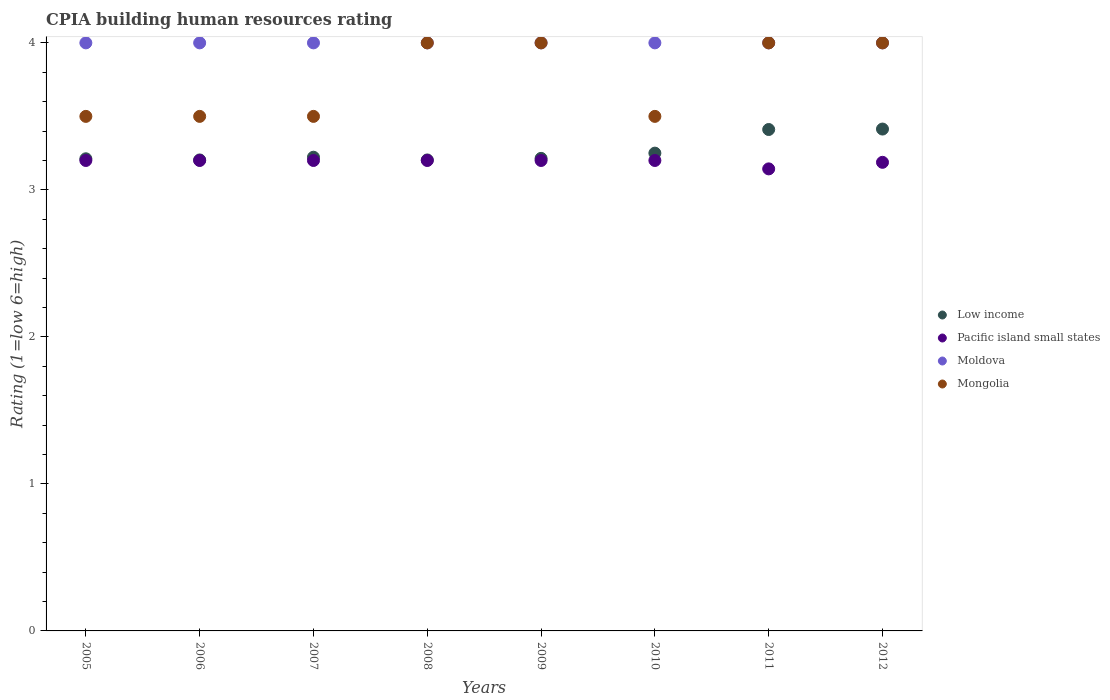In which year was the CPIA rating in Mongolia maximum?
Give a very brief answer. 2008. What is the total CPIA rating in Mongolia in the graph?
Provide a succinct answer. 30. What is the difference between the CPIA rating in Pacific island small states in 2012 and the CPIA rating in Low income in 2007?
Your response must be concise. -0.03. What is the average CPIA rating in Mongolia per year?
Your response must be concise. 3.75. In the year 2009, what is the difference between the CPIA rating in Mongolia and CPIA rating in Pacific island small states?
Offer a very short reply. 0.8. In how many years, is the CPIA rating in Mongolia greater than 2.2?
Provide a succinct answer. 8. Is the CPIA rating in Moldova in 2005 less than that in 2011?
Provide a succinct answer. No. Is the difference between the CPIA rating in Mongolia in 2005 and 2009 greater than the difference between the CPIA rating in Pacific island small states in 2005 and 2009?
Give a very brief answer. No. What is the difference between the highest and the lowest CPIA rating in Low income?
Give a very brief answer. 0.21. In how many years, is the CPIA rating in Low income greater than the average CPIA rating in Low income taken over all years?
Give a very brief answer. 2. Is the sum of the CPIA rating in Pacific island small states in 2009 and 2010 greater than the maximum CPIA rating in Mongolia across all years?
Keep it short and to the point. Yes. Is it the case that in every year, the sum of the CPIA rating in Pacific island small states and CPIA rating in Low income  is greater than the CPIA rating in Moldova?
Offer a terse response. Yes. Does the CPIA rating in Pacific island small states monotonically increase over the years?
Your response must be concise. No. Is the CPIA rating in Pacific island small states strictly greater than the CPIA rating in Low income over the years?
Offer a terse response. No. Is the CPIA rating in Mongolia strictly less than the CPIA rating in Pacific island small states over the years?
Make the answer very short. No. How many dotlines are there?
Offer a terse response. 4. How many years are there in the graph?
Keep it short and to the point. 8. Are the values on the major ticks of Y-axis written in scientific E-notation?
Offer a very short reply. No. Does the graph contain any zero values?
Keep it short and to the point. No. Does the graph contain grids?
Your answer should be compact. No. Where does the legend appear in the graph?
Make the answer very short. Center right. How many legend labels are there?
Ensure brevity in your answer.  4. How are the legend labels stacked?
Offer a very short reply. Vertical. What is the title of the graph?
Your answer should be compact. CPIA building human resources rating. What is the label or title of the Y-axis?
Keep it short and to the point. Rating (1=low 6=high). What is the Rating (1=low 6=high) in Low income in 2005?
Your answer should be compact. 3.21. What is the Rating (1=low 6=high) in Mongolia in 2005?
Offer a terse response. 3.5. What is the Rating (1=low 6=high) in Low income in 2006?
Make the answer very short. 3.2. What is the Rating (1=low 6=high) of Pacific island small states in 2006?
Provide a succinct answer. 3.2. What is the Rating (1=low 6=high) of Moldova in 2006?
Your response must be concise. 4. What is the Rating (1=low 6=high) of Low income in 2007?
Your answer should be very brief. 3.22. What is the Rating (1=low 6=high) of Moldova in 2007?
Ensure brevity in your answer.  4. What is the Rating (1=low 6=high) of Low income in 2008?
Your answer should be compact. 3.2. What is the Rating (1=low 6=high) of Moldova in 2008?
Your response must be concise. 4. What is the Rating (1=low 6=high) in Mongolia in 2008?
Keep it short and to the point. 4. What is the Rating (1=low 6=high) of Low income in 2009?
Your response must be concise. 3.21. What is the Rating (1=low 6=high) in Low income in 2010?
Give a very brief answer. 3.25. What is the Rating (1=low 6=high) of Pacific island small states in 2010?
Offer a very short reply. 3.2. What is the Rating (1=low 6=high) in Moldova in 2010?
Provide a succinct answer. 4. What is the Rating (1=low 6=high) of Low income in 2011?
Your response must be concise. 3.41. What is the Rating (1=low 6=high) in Pacific island small states in 2011?
Offer a terse response. 3.14. What is the Rating (1=low 6=high) in Moldova in 2011?
Provide a short and direct response. 4. What is the Rating (1=low 6=high) of Mongolia in 2011?
Keep it short and to the point. 4. What is the Rating (1=low 6=high) of Low income in 2012?
Make the answer very short. 3.41. What is the Rating (1=low 6=high) in Pacific island small states in 2012?
Provide a succinct answer. 3.19. Across all years, what is the maximum Rating (1=low 6=high) in Low income?
Provide a short and direct response. 3.41. Across all years, what is the maximum Rating (1=low 6=high) in Pacific island small states?
Offer a terse response. 3.2. Across all years, what is the maximum Rating (1=low 6=high) of Moldova?
Your answer should be very brief. 4. Across all years, what is the minimum Rating (1=low 6=high) of Low income?
Provide a short and direct response. 3.2. Across all years, what is the minimum Rating (1=low 6=high) of Pacific island small states?
Ensure brevity in your answer.  3.14. Across all years, what is the minimum Rating (1=low 6=high) in Moldova?
Your answer should be compact. 4. Across all years, what is the minimum Rating (1=low 6=high) of Mongolia?
Ensure brevity in your answer.  3.5. What is the total Rating (1=low 6=high) in Low income in the graph?
Provide a succinct answer. 26.13. What is the total Rating (1=low 6=high) in Pacific island small states in the graph?
Provide a succinct answer. 25.53. What is the total Rating (1=low 6=high) of Moldova in the graph?
Give a very brief answer. 32. What is the difference between the Rating (1=low 6=high) of Low income in 2005 and that in 2006?
Make the answer very short. 0.01. What is the difference between the Rating (1=low 6=high) of Pacific island small states in 2005 and that in 2006?
Provide a short and direct response. 0. What is the difference between the Rating (1=low 6=high) in Low income in 2005 and that in 2007?
Your answer should be very brief. -0.01. What is the difference between the Rating (1=low 6=high) of Pacific island small states in 2005 and that in 2007?
Offer a very short reply. 0. What is the difference between the Rating (1=low 6=high) in Moldova in 2005 and that in 2007?
Your answer should be very brief. 0. What is the difference between the Rating (1=low 6=high) in Mongolia in 2005 and that in 2007?
Make the answer very short. 0. What is the difference between the Rating (1=low 6=high) in Low income in 2005 and that in 2008?
Give a very brief answer. 0.01. What is the difference between the Rating (1=low 6=high) in Moldova in 2005 and that in 2008?
Provide a succinct answer. 0. What is the difference between the Rating (1=low 6=high) of Mongolia in 2005 and that in 2008?
Keep it short and to the point. -0.5. What is the difference between the Rating (1=low 6=high) of Low income in 2005 and that in 2009?
Give a very brief answer. -0. What is the difference between the Rating (1=low 6=high) of Pacific island small states in 2005 and that in 2009?
Provide a succinct answer. 0. What is the difference between the Rating (1=low 6=high) of Mongolia in 2005 and that in 2009?
Keep it short and to the point. -0.5. What is the difference between the Rating (1=low 6=high) of Low income in 2005 and that in 2010?
Keep it short and to the point. -0.04. What is the difference between the Rating (1=low 6=high) in Pacific island small states in 2005 and that in 2010?
Ensure brevity in your answer.  0. What is the difference between the Rating (1=low 6=high) in Moldova in 2005 and that in 2010?
Provide a short and direct response. 0. What is the difference between the Rating (1=low 6=high) in Low income in 2005 and that in 2011?
Keep it short and to the point. -0.2. What is the difference between the Rating (1=low 6=high) of Pacific island small states in 2005 and that in 2011?
Your answer should be very brief. 0.06. What is the difference between the Rating (1=low 6=high) of Moldova in 2005 and that in 2011?
Keep it short and to the point. 0. What is the difference between the Rating (1=low 6=high) of Mongolia in 2005 and that in 2011?
Ensure brevity in your answer.  -0.5. What is the difference between the Rating (1=low 6=high) of Low income in 2005 and that in 2012?
Ensure brevity in your answer.  -0.2. What is the difference between the Rating (1=low 6=high) in Pacific island small states in 2005 and that in 2012?
Give a very brief answer. 0.01. What is the difference between the Rating (1=low 6=high) in Moldova in 2005 and that in 2012?
Your answer should be very brief. 0. What is the difference between the Rating (1=low 6=high) in Mongolia in 2005 and that in 2012?
Your answer should be very brief. -0.5. What is the difference between the Rating (1=low 6=high) in Low income in 2006 and that in 2007?
Offer a terse response. -0.02. What is the difference between the Rating (1=low 6=high) of Pacific island small states in 2006 and that in 2007?
Keep it short and to the point. 0. What is the difference between the Rating (1=low 6=high) in Mongolia in 2006 and that in 2007?
Provide a succinct answer. 0. What is the difference between the Rating (1=low 6=high) of Low income in 2006 and that in 2008?
Provide a succinct answer. 0. What is the difference between the Rating (1=low 6=high) of Pacific island small states in 2006 and that in 2008?
Give a very brief answer. 0. What is the difference between the Rating (1=low 6=high) of Moldova in 2006 and that in 2008?
Your answer should be very brief. 0. What is the difference between the Rating (1=low 6=high) in Mongolia in 2006 and that in 2008?
Give a very brief answer. -0.5. What is the difference between the Rating (1=low 6=high) of Low income in 2006 and that in 2009?
Provide a succinct answer. -0.01. What is the difference between the Rating (1=low 6=high) of Pacific island small states in 2006 and that in 2009?
Give a very brief answer. 0. What is the difference between the Rating (1=low 6=high) of Moldova in 2006 and that in 2009?
Your answer should be compact. 0. What is the difference between the Rating (1=low 6=high) of Mongolia in 2006 and that in 2009?
Ensure brevity in your answer.  -0.5. What is the difference between the Rating (1=low 6=high) of Low income in 2006 and that in 2010?
Give a very brief answer. -0.05. What is the difference between the Rating (1=low 6=high) of Pacific island small states in 2006 and that in 2010?
Ensure brevity in your answer.  0. What is the difference between the Rating (1=low 6=high) of Low income in 2006 and that in 2011?
Provide a succinct answer. -0.21. What is the difference between the Rating (1=low 6=high) in Pacific island small states in 2006 and that in 2011?
Give a very brief answer. 0.06. What is the difference between the Rating (1=low 6=high) in Low income in 2006 and that in 2012?
Provide a short and direct response. -0.21. What is the difference between the Rating (1=low 6=high) in Pacific island small states in 2006 and that in 2012?
Give a very brief answer. 0.01. What is the difference between the Rating (1=low 6=high) in Moldova in 2006 and that in 2012?
Ensure brevity in your answer.  0. What is the difference between the Rating (1=low 6=high) in Mongolia in 2006 and that in 2012?
Your answer should be very brief. -0.5. What is the difference between the Rating (1=low 6=high) in Low income in 2007 and that in 2008?
Give a very brief answer. 0.02. What is the difference between the Rating (1=low 6=high) in Moldova in 2007 and that in 2008?
Offer a terse response. 0. What is the difference between the Rating (1=low 6=high) in Mongolia in 2007 and that in 2008?
Keep it short and to the point. -0.5. What is the difference between the Rating (1=low 6=high) of Low income in 2007 and that in 2009?
Give a very brief answer. 0.01. What is the difference between the Rating (1=low 6=high) of Mongolia in 2007 and that in 2009?
Provide a short and direct response. -0.5. What is the difference between the Rating (1=low 6=high) in Low income in 2007 and that in 2010?
Your answer should be compact. -0.03. What is the difference between the Rating (1=low 6=high) in Pacific island small states in 2007 and that in 2010?
Your answer should be compact. 0. What is the difference between the Rating (1=low 6=high) of Moldova in 2007 and that in 2010?
Your response must be concise. 0. What is the difference between the Rating (1=low 6=high) of Mongolia in 2007 and that in 2010?
Give a very brief answer. 0. What is the difference between the Rating (1=low 6=high) in Low income in 2007 and that in 2011?
Provide a succinct answer. -0.19. What is the difference between the Rating (1=low 6=high) of Pacific island small states in 2007 and that in 2011?
Your answer should be very brief. 0.06. What is the difference between the Rating (1=low 6=high) in Mongolia in 2007 and that in 2011?
Make the answer very short. -0.5. What is the difference between the Rating (1=low 6=high) in Low income in 2007 and that in 2012?
Your answer should be compact. -0.19. What is the difference between the Rating (1=low 6=high) in Pacific island small states in 2007 and that in 2012?
Give a very brief answer. 0.01. What is the difference between the Rating (1=low 6=high) in Moldova in 2007 and that in 2012?
Keep it short and to the point. 0. What is the difference between the Rating (1=low 6=high) of Mongolia in 2007 and that in 2012?
Offer a very short reply. -0.5. What is the difference between the Rating (1=low 6=high) in Low income in 2008 and that in 2009?
Your answer should be very brief. -0.01. What is the difference between the Rating (1=low 6=high) of Pacific island small states in 2008 and that in 2009?
Your answer should be very brief. 0. What is the difference between the Rating (1=low 6=high) of Mongolia in 2008 and that in 2009?
Offer a terse response. 0. What is the difference between the Rating (1=low 6=high) of Low income in 2008 and that in 2010?
Your response must be concise. -0.05. What is the difference between the Rating (1=low 6=high) in Moldova in 2008 and that in 2010?
Provide a short and direct response. 0. What is the difference between the Rating (1=low 6=high) of Mongolia in 2008 and that in 2010?
Keep it short and to the point. 0.5. What is the difference between the Rating (1=low 6=high) of Low income in 2008 and that in 2011?
Your answer should be very brief. -0.21. What is the difference between the Rating (1=low 6=high) of Pacific island small states in 2008 and that in 2011?
Give a very brief answer. 0.06. What is the difference between the Rating (1=low 6=high) of Low income in 2008 and that in 2012?
Your response must be concise. -0.21. What is the difference between the Rating (1=low 6=high) of Pacific island small states in 2008 and that in 2012?
Ensure brevity in your answer.  0.01. What is the difference between the Rating (1=low 6=high) in Moldova in 2008 and that in 2012?
Make the answer very short. 0. What is the difference between the Rating (1=low 6=high) in Mongolia in 2008 and that in 2012?
Provide a short and direct response. 0. What is the difference between the Rating (1=low 6=high) in Low income in 2009 and that in 2010?
Ensure brevity in your answer.  -0.04. What is the difference between the Rating (1=low 6=high) of Moldova in 2009 and that in 2010?
Offer a terse response. 0. What is the difference between the Rating (1=low 6=high) in Mongolia in 2009 and that in 2010?
Your response must be concise. 0.5. What is the difference between the Rating (1=low 6=high) of Low income in 2009 and that in 2011?
Your answer should be compact. -0.2. What is the difference between the Rating (1=low 6=high) of Pacific island small states in 2009 and that in 2011?
Your answer should be very brief. 0.06. What is the difference between the Rating (1=low 6=high) in Low income in 2009 and that in 2012?
Make the answer very short. -0.2. What is the difference between the Rating (1=low 6=high) of Pacific island small states in 2009 and that in 2012?
Offer a terse response. 0.01. What is the difference between the Rating (1=low 6=high) of Moldova in 2009 and that in 2012?
Give a very brief answer. 0. What is the difference between the Rating (1=low 6=high) of Low income in 2010 and that in 2011?
Make the answer very short. -0.16. What is the difference between the Rating (1=low 6=high) of Pacific island small states in 2010 and that in 2011?
Keep it short and to the point. 0.06. What is the difference between the Rating (1=low 6=high) of Mongolia in 2010 and that in 2011?
Provide a succinct answer. -0.5. What is the difference between the Rating (1=low 6=high) of Low income in 2010 and that in 2012?
Give a very brief answer. -0.16. What is the difference between the Rating (1=low 6=high) of Pacific island small states in 2010 and that in 2012?
Your response must be concise. 0.01. What is the difference between the Rating (1=low 6=high) of Moldova in 2010 and that in 2012?
Provide a succinct answer. 0. What is the difference between the Rating (1=low 6=high) of Mongolia in 2010 and that in 2012?
Make the answer very short. -0.5. What is the difference between the Rating (1=low 6=high) of Low income in 2011 and that in 2012?
Give a very brief answer. -0. What is the difference between the Rating (1=low 6=high) in Pacific island small states in 2011 and that in 2012?
Give a very brief answer. -0.04. What is the difference between the Rating (1=low 6=high) of Mongolia in 2011 and that in 2012?
Make the answer very short. 0. What is the difference between the Rating (1=low 6=high) in Low income in 2005 and the Rating (1=low 6=high) in Pacific island small states in 2006?
Your response must be concise. 0.01. What is the difference between the Rating (1=low 6=high) in Low income in 2005 and the Rating (1=low 6=high) in Moldova in 2006?
Your response must be concise. -0.79. What is the difference between the Rating (1=low 6=high) in Low income in 2005 and the Rating (1=low 6=high) in Mongolia in 2006?
Ensure brevity in your answer.  -0.29. What is the difference between the Rating (1=low 6=high) of Pacific island small states in 2005 and the Rating (1=low 6=high) of Mongolia in 2006?
Your answer should be very brief. -0.3. What is the difference between the Rating (1=low 6=high) of Low income in 2005 and the Rating (1=low 6=high) of Pacific island small states in 2007?
Keep it short and to the point. 0.01. What is the difference between the Rating (1=low 6=high) in Low income in 2005 and the Rating (1=low 6=high) in Moldova in 2007?
Provide a succinct answer. -0.79. What is the difference between the Rating (1=low 6=high) in Low income in 2005 and the Rating (1=low 6=high) in Mongolia in 2007?
Your response must be concise. -0.29. What is the difference between the Rating (1=low 6=high) of Low income in 2005 and the Rating (1=low 6=high) of Pacific island small states in 2008?
Offer a terse response. 0.01. What is the difference between the Rating (1=low 6=high) of Low income in 2005 and the Rating (1=low 6=high) of Moldova in 2008?
Keep it short and to the point. -0.79. What is the difference between the Rating (1=low 6=high) in Low income in 2005 and the Rating (1=low 6=high) in Mongolia in 2008?
Ensure brevity in your answer.  -0.79. What is the difference between the Rating (1=low 6=high) in Moldova in 2005 and the Rating (1=low 6=high) in Mongolia in 2008?
Keep it short and to the point. 0. What is the difference between the Rating (1=low 6=high) in Low income in 2005 and the Rating (1=low 6=high) in Pacific island small states in 2009?
Ensure brevity in your answer.  0.01. What is the difference between the Rating (1=low 6=high) of Low income in 2005 and the Rating (1=low 6=high) of Moldova in 2009?
Provide a succinct answer. -0.79. What is the difference between the Rating (1=low 6=high) in Low income in 2005 and the Rating (1=low 6=high) in Mongolia in 2009?
Offer a very short reply. -0.79. What is the difference between the Rating (1=low 6=high) in Pacific island small states in 2005 and the Rating (1=low 6=high) in Mongolia in 2009?
Make the answer very short. -0.8. What is the difference between the Rating (1=low 6=high) in Moldova in 2005 and the Rating (1=low 6=high) in Mongolia in 2009?
Your answer should be very brief. 0. What is the difference between the Rating (1=low 6=high) in Low income in 2005 and the Rating (1=low 6=high) in Pacific island small states in 2010?
Your answer should be very brief. 0.01. What is the difference between the Rating (1=low 6=high) in Low income in 2005 and the Rating (1=low 6=high) in Moldova in 2010?
Provide a succinct answer. -0.79. What is the difference between the Rating (1=low 6=high) of Low income in 2005 and the Rating (1=low 6=high) of Mongolia in 2010?
Offer a very short reply. -0.29. What is the difference between the Rating (1=low 6=high) of Pacific island small states in 2005 and the Rating (1=low 6=high) of Mongolia in 2010?
Offer a terse response. -0.3. What is the difference between the Rating (1=low 6=high) in Moldova in 2005 and the Rating (1=low 6=high) in Mongolia in 2010?
Give a very brief answer. 0.5. What is the difference between the Rating (1=low 6=high) of Low income in 2005 and the Rating (1=low 6=high) of Pacific island small states in 2011?
Provide a succinct answer. 0.07. What is the difference between the Rating (1=low 6=high) of Low income in 2005 and the Rating (1=low 6=high) of Moldova in 2011?
Offer a very short reply. -0.79. What is the difference between the Rating (1=low 6=high) in Low income in 2005 and the Rating (1=low 6=high) in Mongolia in 2011?
Offer a very short reply. -0.79. What is the difference between the Rating (1=low 6=high) of Moldova in 2005 and the Rating (1=low 6=high) of Mongolia in 2011?
Your answer should be compact. 0. What is the difference between the Rating (1=low 6=high) of Low income in 2005 and the Rating (1=low 6=high) of Pacific island small states in 2012?
Ensure brevity in your answer.  0.02. What is the difference between the Rating (1=low 6=high) in Low income in 2005 and the Rating (1=low 6=high) in Moldova in 2012?
Make the answer very short. -0.79. What is the difference between the Rating (1=low 6=high) in Low income in 2005 and the Rating (1=low 6=high) in Mongolia in 2012?
Provide a short and direct response. -0.79. What is the difference between the Rating (1=low 6=high) of Pacific island small states in 2005 and the Rating (1=low 6=high) of Moldova in 2012?
Make the answer very short. -0.8. What is the difference between the Rating (1=low 6=high) of Moldova in 2005 and the Rating (1=low 6=high) of Mongolia in 2012?
Offer a terse response. 0. What is the difference between the Rating (1=low 6=high) in Low income in 2006 and the Rating (1=low 6=high) in Pacific island small states in 2007?
Your response must be concise. 0. What is the difference between the Rating (1=low 6=high) in Low income in 2006 and the Rating (1=low 6=high) in Moldova in 2007?
Offer a terse response. -0.8. What is the difference between the Rating (1=low 6=high) of Low income in 2006 and the Rating (1=low 6=high) of Mongolia in 2007?
Provide a succinct answer. -0.3. What is the difference between the Rating (1=low 6=high) of Pacific island small states in 2006 and the Rating (1=low 6=high) of Mongolia in 2007?
Keep it short and to the point. -0.3. What is the difference between the Rating (1=low 6=high) in Low income in 2006 and the Rating (1=low 6=high) in Pacific island small states in 2008?
Provide a short and direct response. 0. What is the difference between the Rating (1=low 6=high) of Low income in 2006 and the Rating (1=low 6=high) of Moldova in 2008?
Make the answer very short. -0.8. What is the difference between the Rating (1=low 6=high) of Low income in 2006 and the Rating (1=low 6=high) of Mongolia in 2008?
Offer a terse response. -0.8. What is the difference between the Rating (1=low 6=high) in Pacific island small states in 2006 and the Rating (1=low 6=high) in Mongolia in 2008?
Your response must be concise. -0.8. What is the difference between the Rating (1=low 6=high) in Low income in 2006 and the Rating (1=low 6=high) in Pacific island small states in 2009?
Your answer should be compact. 0. What is the difference between the Rating (1=low 6=high) of Low income in 2006 and the Rating (1=low 6=high) of Moldova in 2009?
Offer a very short reply. -0.8. What is the difference between the Rating (1=low 6=high) of Low income in 2006 and the Rating (1=low 6=high) of Mongolia in 2009?
Your response must be concise. -0.8. What is the difference between the Rating (1=low 6=high) in Pacific island small states in 2006 and the Rating (1=low 6=high) in Moldova in 2009?
Offer a terse response. -0.8. What is the difference between the Rating (1=low 6=high) of Pacific island small states in 2006 and the Rating (1=low 6=high) of Mongolia in 2009?
Give a very brief answer. -0.8. What is the difference between the Rating (1=low 6=high) in Low income in 2006 and the Rating (1=low 6=high) in Pacific island small states in 2010?
Your answer should be very brief. 0. What is the difference between the Rating (1=low 6=high) of Low income in 2006 and the Rating (1=low 6=high) of Moldova in 2010?
Offer a very short reply. -0.8. What is the difference between the Rating (1=low 6=high) of Low income in 2006 and the Rating (1=low 6=high) of Mongolia in 2010?
Offer a terse response. -0.3. What is the difference between the Rating (1=low 6=high) in Pacific island small states in 2006 and the Rating (1=low 6=high) in Moldova in 2010?
Make the answer very short. -0.8. What is the difference between the Rating (1=low 6=high) of Pacific island small states in 2006 and the Rating (1=low 6=high) of Mongolia in 2010?
Ensure brevity in your answer.  -0.3. What is the difference between the Rating (1=low 6=high) of Moldova in 2006 and the Rating (1=low 6=high) of Mongolia in 2010?
Give a very brief answer. 0.5. What is the difference between the Rating (1=low 6=high) of Low income in 2006 and the Rating (1=low 6=high) of Pacific island small states in 2011?
Your response must be concise. 0.06. What is the difference between the Rating (1=low 6=high) in Low income in 2006 and the Rating (1=low 6=high) in Moldova in 2011?
Make the answer very short. -0.8. What is the difference between the Rating (1=low 6=high) in Low income in 2006 and the Rating (1=low 6=high) in Mongolia in 2011?
Make the answer very short. -0.8. What is the difference between the Rating (1=low 6=high) in Pacific island small states in 2006 and the Rating (1=low 6=high) in Mongolia in 2011?
Offer a terse response. -0.8. What is the difference between the Rating (1=low 6=high) of Low income in 2006 and the Rating (1=low 6=high) of Pacific island small states in 2012?
Offer a very short reply. 0.02. What is the difference between the Rating (1=low 6=high) in Low income in 2006 and the Rating (1=low 6=high) in Moldova in 2012?
Make the answer very short. -0.8. What is the difference between the Rating (1=low 6=high) of Low income in 2006 and the Rating (1=low 6=high) of Mongolia in 2012?
Ensure brevity in your answer.  -0.8. What is the difference between the Rating (1=low 6=high) in Pacific island small states in 2006 and the Rating (1=low 6=high) in Moldova in 2012?
Offer a very short reply. -0.8. What is the difference between the Rating (1=low 6=high) of Pacific island small states in 2006 and the Rating (1=low 6=high) of Mongolia in 2012?
Offer a very short reply. -0.8. What is the difference between the Rating (1=low 6=high) of Moldova in 2006 and the Rating (1=low 6=high) of Mongolia in 2012?
Your answer should be very brief. 0. What is the difference between the Rating (1=low 6=high) in Low income in 2007 and the Rating (1=low 6=high) in Pacific island small states in 2008?
Give a very brief answer. 0.02. What is the difference between the Rating (1=low 6=high) in Low income in 2007 and the Rating (1=low 6=high) in Moldova in 2008?
Offer a very short reply. -0.78. What is the difference between the Rating (1=low 6=high) in Low income in 2007 and the Rating (1=low 6=high) in Mongolia in 2008?
Ensure brevity in your answer.  -0.78. What is the difference between the Rating (1=low 6=high) of Pacific island small states in 2007 and the Rating (1=low 6=high) of Mongolia in 2008?
Your answer should be compact. -0.8. What is the difference between the Rating (1=low 6=high) in Low income in 2007 and the Rating (1=low 6=high) in Pacific island small states in 2009?
Your answer should be very brief. 0.02. What is the difference between the Rating (1=low 6=high) of Low income in 2007 and the Rating (1=low 6=high) of Moldova in 2009?
Offer a very short reply. -0.78. What is the difference between the Rating (1=low 6=high) in Low income in 2007 and the Rating (1=low 6=high) in Mongolia in 2009?
Your response must be concise. -0.78. What is the difference between the Rating (1=low 6=high) in Low income in 2007 and the Rating (1=low 6=high) in Pacific island small states in 2010?
Your answer should be very brief. 0.02. What is the difference between the Rating (1=low 6=high) of Low income in 2007 and the Rating (1=low 6=high) of Moldova in 2010?
Your response must be concise. -0.78. What is the difference between the Rating (1=low 6=high) of Low income in 2007 and the Rating (1=low 6=high) of Mongolia in 2010?
Ensure brevity in your answer.  -0.28. What is the difference between the Rating (1=low 6=high) of Pacific island small states in 2007 and the Rating (1=low 6=high) of Moldova in 2010?
Ensure brevity in your answer.  -0.8. What is the difference between the Rating (1=low 6=high) of Low income in 2007 and the Rating (1=low 6=high) of Pacific island small states in 2011?
Keep it short and to the point. 0.08. What is the difference between the Rating (1=low 6=high) in Low income in 2007 and the Rating (1=low 6=high) in Moldova in 2011?
Make the answer very short. -0.78. What is the difference between the Rating (1=low 6=high) of Low income in 2007 and the Rating (1=low 6=high) of Mongolia in 2011?
Make the answer very short. -0.78. What is the difference between the Rating (1=low 6=high) in Pacific island small states in 2007 and the Rating (1=low 6=high) in Moldova in 2011?
Offer a very short reply. -0.8. What is the difference between the Rating (1=low 6=high) of Moldova in 2007 and the Rating (1=low 6=high) of Mongolia in 2011?
Keep it short and to the point. 0. What is the difference between the Rating (1=low 6=high) of Low income in 2007 and the Rating (1=low 6=high) of Pacific island small states in 2012?
Your answer should be compact. 0.03. What is the difference between the Rating (1=low 6=high) in Low income in 2007 and the Rating (1=low 6=high) in Moldova in 2012?
Keep it short and to the point. -0.78. What is the difference between the Rating (1=low 6=high) in Low income in 2007 and the Rating (1=low 6=high) in Mongolia in 2012?
Offer a very short reply. -0.78. What is the difference between the Rating (1=low 6=high) in Pacific island small states in 2007 and the Rating (1=low 6=high) in Moldova in 2012?
Offer a terse response. -0.8. What is the difference between the Rating (1=low 6=high) of Pacific island small states in 2007 and the Rating (1=low 6=high) of Mongolia in 2012?
Keep it short and to the point. -0.8. What is the difference between the Rating (1=low 6=high) of Low income in 2008 and the Rating (1=low 6=high) of Pacific island small states in 2009?
Give a very brief answer. 0. What is the difference between the Rating (1=low 6=high) of Low income in 2008 and the Rating (1=low 6=high) of Moldova in 2009?
Keep it short and to the point. -0.8. What is the difference between the Rating (1=low 6=high) of Low income in 2008 and the Rating (1=low 6=high) of Mongolia in 2009?
Your answer should be very brief. -0.8. What is the difference between the Rating (1=low 6=high) of Pacific island small states in 2008 and the Rating (1=low 6=high) of Mongolia in 2009?
Make the answer very short. -0.8. What is the difference between the Rating (1=low 6=high) of Moldova in 2008 and the Rating (1=low 6=high) of Mongolia in 2009?
Provide a short and direct response. 0. What is the difference between the Rating (1=low 6=high) of Low income in 2008 and the Rating (1=low 6=high) of Pacific island small states in 2010?
Ensure brevity in your answer.  0. What is the difference between the Rating (1=low 6=high) in Low income in 2008 and the Rating (1=low 6=high) in Moldova in 2010?
Give a very brief answer. -0.8. What is the difference between the Rating (1=low 6=high) in Low income in 2008 and the Rating (1=low 6=high) in Mongolia in 2010?
Keep it short and to the point. -0.3. What is the difference between the Rating (1=low 6=high) in Pacific island small states in 2008 and the Rating (1=low 6=high) in Moldova in 2010?
Give a very brief answer. -0.8. What is the difference between the Rating (1=low 6=high) of Pacific island small states in 2008 and the Rating (1=low 6=high) of Mongolia in 2010?
Ensure brevity in your answer.  -0.3. What is the difference between the Rating (1=low 6=high) in Moldova in 2008 and the Rating (1=low 6=high) in Mongolia in 2010?
Your response must be concise. 0.5. What is the difference between the Rating (1=low 6=high) of Low income in 2008 and the Rating (1=low 6=high) of Pacific island small states in 2011?
Provide a succinct answer. 0.06. What is the difference between the Rating (1=low 6=high) of Low income in 2008 and the Rating (1=low 6=high) of Moldova in 2011?
Offer a terse response. -0.8. What is the difference between the Rating (1=low 6=high) in Low income in 2008 and the Rating (1=low 6=high) in Mongolia in 2011?
Give a very brief answer. -0.8. What is the difference between the Rating (1=low 6=high) of Pacific island small states in 2008 and the Rating (1=low 6=high) of Moldova in 2011?
Offer a terse response. -0.8. What is the difference between the Rating (1=low 6=high) in Moldova in 2008 and the Rating (1=low 6=high) in Mongolia in 2011?
Make the answer very short. 0. What is the difference between the Rating (1=low 6=high) in Low income in 2008 and the Rating (1=low 6=high) in Pacific island small states in 2012?
Ensure brevity in your answer.  0.02. What is the difference between the Rating (1=low 6=high) in Low income in 2008 and the Rating (1=low 6=high) in Moldova in 2012?
Keep it short and to the point. -0.8. What is the difference between the Rating (1=low 6=high) of Low income in 2008 and the Rating (1=low 6=high) of Mongolia in 2012?
Provide a short and direct response. -0.8. What is the difference between the Rating (1=low 6=high) of Pacific island small states in 2008 and the Rating (1=low 6=high) of Mongolia in 2012?
Your answer should be very brief. -0.8. What is the difference between the Rating (1=low 6=high) of Moldova in 2008 and the Rating (1=low 6=high) of Mongolia in 2012?
Provide a short and direct response. 0. What is the difference between the Rating (1=low 6=high) of Low income in 2009 and the Rating (1=low 6=high) of Pacific island small states in 2010?
Your answer should be compact. 0.01. What is the difference between the Rating (1=low 6=high) of Low income in 2009 and the Rating (1=low 6=high) of Moldova in 2010?
Your response must be concise. -0.79. What is the difference between the Rating (1=low 6=high) in Low income in 2009 and the Rating (1=low 6=high) in Mongolia in 2010?
Make the answer very short. -0.29. What is the difference between the Rating (1=low 6=high) of Low income in 2009 and the Rating (1=low 6=high) of Pacific island small states in 2011?
Keep it short and to the point. 0.07. What is the difference between the Rating (1=low 6=high) of Low income in 2009 and the Rating (1=low 6=high) of Moldova in 2011?
Offer a very short reply. -0.79. What is the difference between the Rating (1=low 6=high) of Low income in 2009 and the Rating (1=low 6=high) of Mongolia in 2011?
Provide a short and direct response. -0.79. What is the difference between the Rating (1=low 6=high) of Pacific island small states in 2009 and the Rating (1=low 6=high) of Moldova in 2011?
Provide a succinct answer. -0.8. What is the difference between the Rating (1=low 6=high) of Low income in 2009 and the Rating (1=low 6=high) of Pacific island small states in 2012?
Your answer should be compact. 0.03. What is the difference between the Rating (1=low 6=high) in Low income in 2009 and the Rating (1=low 6=high) in Moldova in 2012?
Your response must be concise. -0.79. What is the difference between the Rating (1=low 6=high) of Low income in 2009 and the Rating (1=low 6=high) of Mongolia in 2012?
Your response must be concise. -0.79. What is the difference between the Rating (1=low 6=high) in Pacific island small states in 2009 and the Rating (1=low 6=high) in Moldova in 2012?
Offer a terse response. -0.8. What is the difference between the Rating (1=low 6=high) in Pacific island small states in 2009 and the Rating (1=low 6=high) in Mongolia in 2012?
Provide a succinct answer. -0.8. What is the difference between the Rating (1=low 6=high) in Moldova in 2009 and the Rating (1=low 6=high) in Mongolia in 2012?
Provide a short and direct response. 0. What is the difference between the Rating (1=low 6=high) of Low income in 2010 and the Rating (1=low 6=high) of Pacific island small states in 2011?
Provide a succinct answer. 0.11. What is the difference between the Rating (1=low 6=high) in Low income in 2010 and the Rating (1=low 6=high) in Moldova in 2011?
Your response must be concise. -0.75. What is the difference between the Rating (1=low 6=high) in Low income in 2010 and the Rating (1=low 6=high) in Mongolia in 2011?
Provide a short and direct response. -0.75. What is the difference between the Rating (1=low 6=high) in Pacific island small states in 2010 and the Rating (1=low 6=high) in Moldova in 2011?
Provide a short and direct response. -0.8. What is the difference between the Rating (1=low 6=high) in Pacific island small states in 2010 and the Rating (1=low 6=high) in Mongolia in 2011?
Provide a short and direct response. -0.8. What is the difference between the Rating (1=low 6=high) in Moldova in 2010 and the Rating (1=low 6=high) in Mongolia in 2011?
Your answer should be compact. 0. What is the difference between the Rating (1=low 6=high) of Low income in 2010 and the Rating (1=low 6=high) of Pacific island small states in 2012?
Offer a very short reply. 0.06. What is the difference between the Rating (1=low 6=high) in Low income in 2010 and the Rating (1=low 6=high) in Moldova in 2012?
Your answer should be compact. -0.75. What is the difference between the Rating (1=low 6=high) of Low income in 2010 and the Rating (1=low 6=high) of Mongolia in 2012?
Ensure brevity in your answer.  -0.75. What is the difference between the Rating (1=low 6=high) in Pacific island small states in 2010 and the Rating (1=low 6=high) in Moldova in 2012?
Your response must be concise. -0.8. What is the difference between the Rating (1=low 6=high) in Pacific island small states in 2010 and the Rating (1=low 6=high) in Mongolia in 2012?
Offer a terse response. -0.8. What is the difference between the Rating (1=low 6=high) of Moldova in 2010 and the Rating (1=low 6=high) of Mongolia in 2012?
Provide a short and direct response. 0. What is the difference between the Rating (1=low 6=high) in Low income in 2011 and the Rating (1=low 6=high) in Pacific island small states in 2012?
Your response must be concise. 0.22. What is the difference between the Rating (1=low 6=high) of Low income in 2011 and the Rating (1=low 6=high) of Moldova in 2012?
Your response must be concise. -0.59. What is the difference between the Rating (1=low 6=high) in Low income in 2011 and the Rating (1=low 6=high) in Mongolia in 2012?
Provide a short and direct response. -0.59. What is the difference between the Rating (1=low 6=high) of Pacific island small states in 2011 and the Rating (1=low 6=high) of Moldova in 2012?
Give a very brief answer. -0.86. What is the difference between the Rating (1=low 6=high) in Pacific island small states in 2011 and the Rating (1=low 6=high) in Mongolia in 2012?
Provide a short and direct response. -0.86. What is the average Rating (1=low 6=high) of Low income per year?
Provide a succinct answer. 3.27. What is the average Rating (1=low 6=high) in Pacific island small states per year?
Provide a succinct answer. 3.19. What is the average Rating (1=low 6=high) in Mongolia per year?
Provide a short and direct response. 3.75. In the year 2005, what is the difference between the Rating (1=low 6=high) in Low income and Rating (1=low 6=high) in Pacific island small states?
Give a very brief answer. 0.01. In the year 2005, what is the difference between the Rating (1=low 6=high) of Low income and Rating (1=low 6=high) of Moldova?
Make the answer very short. -0.79. In the year 2005, what is the difference between the Rating (1=low 6=high) in Low income and Rating (1=low 6=high) in Mongolia?
Give a very brief answer. -0.29. In the year 2005, what is the difference between the Rating (1=low 6=high) of Moldova and Rating (1=low 6=high) of Mongolia?
Your answer should be very brief. 0.5. In the year 2006, what is the difference between the Rating (1=low 6=high) of Low income and Rating (1=low 6=high) of Pacific island small states?
Offer a very short reply. 0. In the year 2006, what is the difference between the Rating (1=low 6=high) of Low income and Rating (1=low 6=high) of Moldova?
Keep it short and to the point. -0.8. In the year 2006, what is the difference between the Rating (1=low 6=high) of Low income and Rating (1=low 6=high) of Mongolia?
Provide a succinct answer. -0.3. In the year 2006, what is the difference between the Rating (1=low 6=high) in Pacific island small states and Rating (1=low 6=high) in Moldova?
Offer a very short reply. -0.8. In the year 2006, what is the difference between the Rating (1=low 6=high) of Pacific island small states and Rating (1=low 6=high) of Mongolia?
Provide a short and direct response. -0.3. In the year 2006, what is the difference between the Rating (1=low 6=high) of Moldova and Rating (1=low 6=high) of Mongolia?
Offer a terse response. 0.5. In the year 2007, what is the difference between the Rating (1=low 6=high) of Low income and Rating (1=low 6=high) of Pacific island small states?
Your answer should be compact. 0.02. In the year 2007, what is the difference between the Rating (1=low 6=high) in Low income and Rating (1=low 6=high) in Moldova?
Your answer should be very brief. -0.78. In the year 2007, what is the difference between the Rating (1=low 6=high) of Low income and Rating (1=low 6=high) of Mongolia?
Give a very brief answer. -0.28. In the year 2007, what is the difference between the Rating (1=low 6=high) of Pacific island small states and Rating (1=low 6=high) of Mongolia?
Your response must be concise. -0.3. In the year 2007, what is the difference between the Rating (1=low 6=high) of Moldova and Rating (1=low 6=high) of Mongolia?
Make the answer very short. 0.5. In the year 2008, what is the difference between the Rating (1=low 6=high) in Low income and Rating (1=low 6=high) in Pacific island small states?
Offer a terse response. 0. In the year 2008, what is the difference between the Rating (1=low 6=high) in Low income and Rating (1=low 6=high) in Moldova?
Provide a short and direct response. -0.8. In the year 2008, what is the difference between the Rating (1=low 6=high) of Low income and Rating (1=low 6=high) of Mongolia?
Provide a succinct answer. -0.8. In the year 2008, what is the difference between the Rating (1=low 6=high) of Pacific island small states and Rating (1=low 6=high) of Mongolia?
Provide a short and direct response. -0.8. In the year 2009, what is the difference between the Rating (1=low 6=high) of Low income and Rating (1=low 6=high) of Pacific island small states?
Offer a terse response. 0.01. In the year 2009, what is the difference between the Rating (1=low 6=high) in Low income and Rating (1=low 6=high) in Moldova?
Your answer should be very brief. -0.79. In the year 2009, what is the difference between the Rating (1=low 6=high) of Low income and Rating (1=low 6=high) of Mongolia?
Offer a very short reply. -0.79. In the year 2009, what is the difference between the Rating (1=low 6=high) in Pacific island small states and Rating (1=low 6=high) in Mongolia?
Your answer should be very brief. -0.8. In the year 2009, what is the difference between the Rating (1=low 6=high) in Moldova and Rating (1=low 6=high) in Mongolia?
Offer a terse response. 0. In the year 2010, what is the difference between the Rating (1=low 6=high) in Low income and Rating (1=low 6=high) in Pacific island small states?
Make the answer very short. 0.05. In the year 2010, what is the difference between the Rating (1=low 6=high) of Low income and Rating (1=low 6=high) of Moldova?
Your response must be concise. -0.75. In the year 2010, what is the difference between the Rating (1=low 6=high) of Pacific island small states and Rating (1=low 6=high) of Mongolia?
Make the answer very short. -0.3. In the year 2011, what is the difference between the Rating (1=low 6=high) in Low income and Rating (1=low 6=high) in Pacific island small states?
Your answer should be compact. 0.27. In the year 2011, what is the difference between the Rating (1=low 6=high) of Low income and Rating (1=low 6=high) of Moldova?
Provide a short and direct response. -0.59. In the year 2011, what is the difference between the Rating (1=low 6=high) in Low income and Rating (1=low 6=high) in Mongolia?
Offer a very short reply. -0.59. In the year 2011, what is the difference between the Rating (1=low 6=high) of Pacific island small states and Rating (1=low 6=high) of Moldova?
Keep it short and to the point. -0.86. In the year 2011, what is the difference between the Rating (1=low 6=high) in Pacific island small states and Rating (1=low 6=high) in Mongolia?
Your response must be concise. -0.86. In the year 2011, what is the difference between the Rating (1=low 6=high) in Moldova and Rating (1=low 6=high) in Mongolia?
Make the answer very short. 0. In the year 2012, what is the difference between the Rating (1=low 6=high) in Low income and Rating (1=low 6=high) in Pacific island small states?
Ensure brevity in your answer.  0.23. In the year 2012, what is the difference between the Rating (1=low 6=high) in Low income and Rating (1=low 6=high) in Moldova?
Keep it short and to the point. -0.59. In the year 2012, what is the difference between the Rating (1=low 6=high) in Low income and Rating (1=low 6=high) in Mongolia?
Give a very brief answer. -0.59. In the year 2012, what is the difference between the Rating (1=low 6=high) of Pacific island small states and Rating (1=low 6=high) of Moldova?
Ensure brevity in your answer.  -0.81. In the year 2012, what is the difference between the Rating (1=low 6=high) of Pacific island small states and Rating (1=low 6=high) of Mongolia?
Give a very brief answer. -0.81. What is the ratio of the Rating (1=low 6=high) in Low income in 2005 to that in 2006?
Offer a terse response. 1. What is the ratio of the Rating (1=low 6=high) of Pacific island small states in 2005 to that in 2006?
Make the answer very short. 1. What is the ratio of the Rating (1=low 6=high) of Moldova in 2005 to that in 2006?
Make the answer very short. 1. What is the ratio of the Rating (1=low 6=high) of Mongolia in 2005 to that in 2006?
Keep it short and to the point. 1. What is the ratio of the Rating (1=low 6=high) in Mongolia in 2005 to that in 2008?
Offer a very short reply. 0.88. What is the ratio of the Rating (1=low 6=high) in Moldova in 2005 to that in 2009?
Give a very brief answer. 1. What is the ratio of the Rating (1=low 6=high) in Mongolia in 2005 to that in 2009?
Your response must be concise. 0.88. What is the ratio of the Rating (1=low 6=high) of Low income in 2005 to that in 2010?
Provide a succinct answer. 0.99. What is the ratio of the Rating (1=low 6=high) in Pacific island small states in 2005 to that in 2010?
Ensure brevity in your answer.  1. What is the ratio of the Rating (1=low 6=high) of Moldova in 2005 to that in 2010?
Keep it short and to the point. 1. What is the ratio of the Rating (1=low 6=high) of Mongolia in 2005 to that in 2010?
Provide a short and direct response. 1. What is the ratio of the Rating (1=low 6=high) in Low income in 2005 to that in 2011?
Your response must be concise. 0.94. What is the ratio of the Rating (1=low 6=high) of Pacific island small states in 2005 to that in 2011?
Offer a terse response. 1.02. What is the ratio of the Rating (1=low 6=high) in Moldova in 2005 to that in 2011?
Keep it short and to the point. 1. What is the ratio of the Rating (1=low 6=high) in Mongolia in 2005 to that in 2011?
Offer a very short reply. 0.88. What is the ratio of the Rating (1=low 6=high) in Low income in 2005 to that in 2012?
Ensure brevity in your answer.  0.94. What is the ratio of the Rating (1=low 6=high) in Pacific island small states in 2005 to that in 2012?
Ensure brevity in your answer.  1. What is the ratio of the Rating (1=low 6=high) in Mongolia in 2005 to that in 2012?
Provide a short and direct response. 0.88. What is the ratio of the Rating (1=low 6=high) in Pacific island small states in 2006 to that in 2007?
Your response must be concise. 1. What is the ratio of the Rating (1=low 6=high) of Pacific island small states in 2006 to that in 2009?
Make the answer very short. 1. What is the ratio of the Rating (1=low 6=high) of Moldova in 2006 to that in 2009?
Offer a terse response. 1. What is the ratio of the Rating (1=low 6=high) of Low income in 2006 to that in 2010?
Provide a short and direct response. 0.99. What is the ratio of the Rating (1=low 6=high) in Mongolia in 2006 to that in 2010?
Your answer should be compact. 1. What is the ratio of the Rating (1=low 6=high) in Low income in 2006 to that in 2011?
Provide a short and direct response. 0.94. What is the ratio of the Rating (1=low 6=high) in Pacific island small states in 2006 to that in 2011?
Provide a succinct answer. 1.02. What is the ratio of the Rating (1=low 6=high) in Moldova in 2006 to that in 2011?
Give a very brief answer. 1. What is the ratio of the Rating (1=low 6=high) of Low income in 2006 to that in 2012?
Offer a terse response. 0.94. What is the ratio of the Rating (1=low 6=high) in Pacific island small states in 2006 to that in 2012?
Your answer should be very brief. 1. What is the ratio of the Rating (1=low 6=high) in Mongolia in 2006 to that in 2012?
Your answer should be very brief. 0.88. What is the ratio of the Rating (1=low 6=high) of Pacific island small states in 2007 to that in 2008?
Provide a short and direct response. 1. What is the ratio of the Rating (1=low 6=high) in Low income in 2007 to that in 2009?
Provide a succinct answer. 1. What is the ratio of the Rating (1=low 6=high) in Moldova in 2007 to that in 2009?
Your answer should be very brief. 1. What is the ratio of the Rating (1=low 6=high) in Mongolia in 2007 to that in 2009?
Offer a terse response. 0.88. What is the ratio of the Rating (1=low 6=high) in Mongolia in 2007 to that in 2010?
Your answer should be very brief. 1. What is the ratio of the Rating (1=low 6=high) of Low income in 2007 to that in 2011?
Ensure brevity in your answer.  0.94. What is the ratio of the Rating (1=low 6=high) in Pacific island small states in 2007 to that in 2011?
Give a very brief answer. 1.02. What is the ratio of the Rating (1=low 6=high) of Moldova in 2007 to that in 2011?
Your answer should be compact. 1. What is the ratio of the Rating (1=low 6=high) of Mongolia in 2007 to that in 2011?
Give a very brief answer. 0.88. What is the ratio of the Rating (1=low 6=high) of Low income in 2007 to that in 2012?
Ensure brevity in your answer.  0.94. What is the ratio of the Rating (1=low 6=high) in Pacific island small states in 2007 to that in 2012?
Your response must be concise. 1. What is the ratio of the Rating (1=low 6=high) in Moldova in 2007 to that in 2012?
Provide a succinct answer. 1. What is the ratio of the Rating (1=low 6=high) of Low income in 2008 to that in 2010?
Offer a very short reply. 0.99. What is the ratio of the Rating (1=low 6=high) of Mongolia in 2008 to that in 2010?
Make the answer very short. 1.14. What is the ratio of the Rating (1=low 6=high) in Low income in 2008 to that in 2011?
Provide a short and direct response. 0.94. What is the ratio of the Rating (1=low 6=high) of Pacific island small states in 2008 to that in 2011?
Your response must be concise. 1.02. What is the ratio of the Rating (1=low 6=high) of Mongolia in 2008 to that in 2011?
Ensure brevity in your answer.  1. What is the ratio of the Rating (1=low 6=high) in Low income in 2008 to that in 2012?
Offer a terse response. 0.94. What is the ratio of the Rating (1=low 6=high) in Pacific island small states in 2008 to that in 2012?
Your response must be concise. 1. What is the ratio of the Rating (1=low 6=high) in Low income in 2009 to that in 2010?
Your response must be concise. 0.99. What is the ratio of the Rating (1=low 6=high) of Pacific island small states in 2009 to that in 2010?
Keep it short and to the point. 1. What is the ratio of the Rating (1=low 6=high) of Low income in 2009 to that in 2011?
Provide a short and direct response. 0.94. What is the ratio of the Rating (1=low 6=high) in Pacific island small states in 2009 to that in 2011?
Offer a terse response. 1.02. What is the ratio of the Rating (1=low 6=high) of Moldova in 2009 to that in 2011?
Your answer should be compact. 1. What is the ratio of the Rating (1=low 6=high) in Low income in 2009 to that in 2012?
Offer a very short reply. 0.94. What is the ratio of the Rating (1=low 6=high) of Mongolia in 2009 to that in 2012?
Your answer should be very brief. 1. What is the ratio of the Rating (1=low 6=high) of Low income in 2010 to that in 2011?
Keep it short and to the point. 0.95. What is the ratio of the Rating (1=low 6=high) of Pacific island small states in 2010 to that in 2011?
Give a very brief answer. 1.02. What is the ratio of the Rating (1=low 6=high) in Moldova in 2010 to that in 2011?
Provide a short and direct response. 1. What is the ratio of the Rating (1=low 6=high) in Low income in 2010 to that in 2012?
Your answer should be compact. 0.95. What is the ratio of the Rating (1=low 6=high) in Pacific island small states in 2010 to that in 2012?
Offer a terse response. 1. What is the ratio of the Rating (1=low 6=high) of Moldova in 2010 to that in 2012?
Give a very brief answer. 1. What is the ratio of the Rating (1=low 6=high) in Mongolia in 2010 to that in 2012?
Your response must be concise. 0.88. What is the difference between the highest and the second highest Rating (1=low 6=high) in Low income?
Ensure brevity in your answer.  0. What is the difference between the highest and the second highest Rating (1=low 6=high) of Mongolia?
Ensure brevity in your answer.  0. What is the difference between the highest and the lowest Rating (1=low 6=high) in Low income?
Make the answer very short. 0.21. What is the difference between the highest and the lowest Rating (1=low 6=high) of Pacific island small states?
Your answer should be compact. 0.06. 